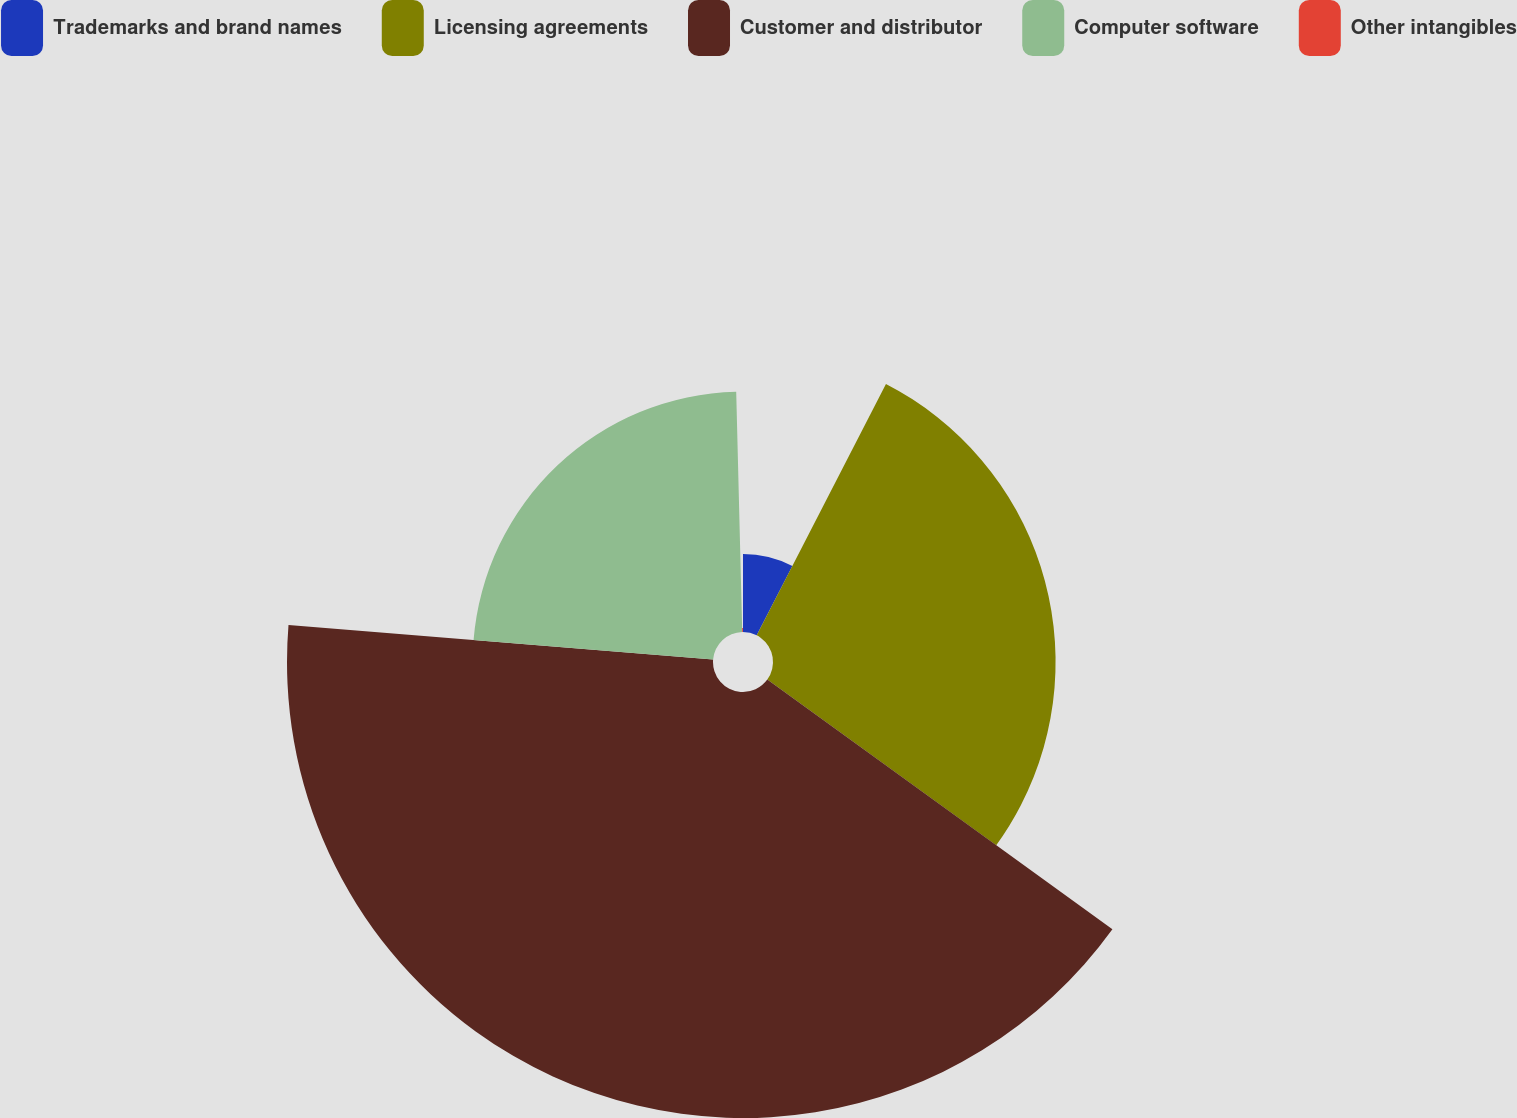Convert chart to OTSL. <chart><loc_0><loc_0><loc_500><loc_500><pie_chart><fcel>Trademarks and brand names<fcel>Licensing agreements<fcel>Customer and distributor<fcel>Computer software<fcel>Other intangibles<nl><fcel>7.56%<fcel>27.41%<fcel>41.32%<fcel>23.31%<fcel>0.4%<nl></chart> 